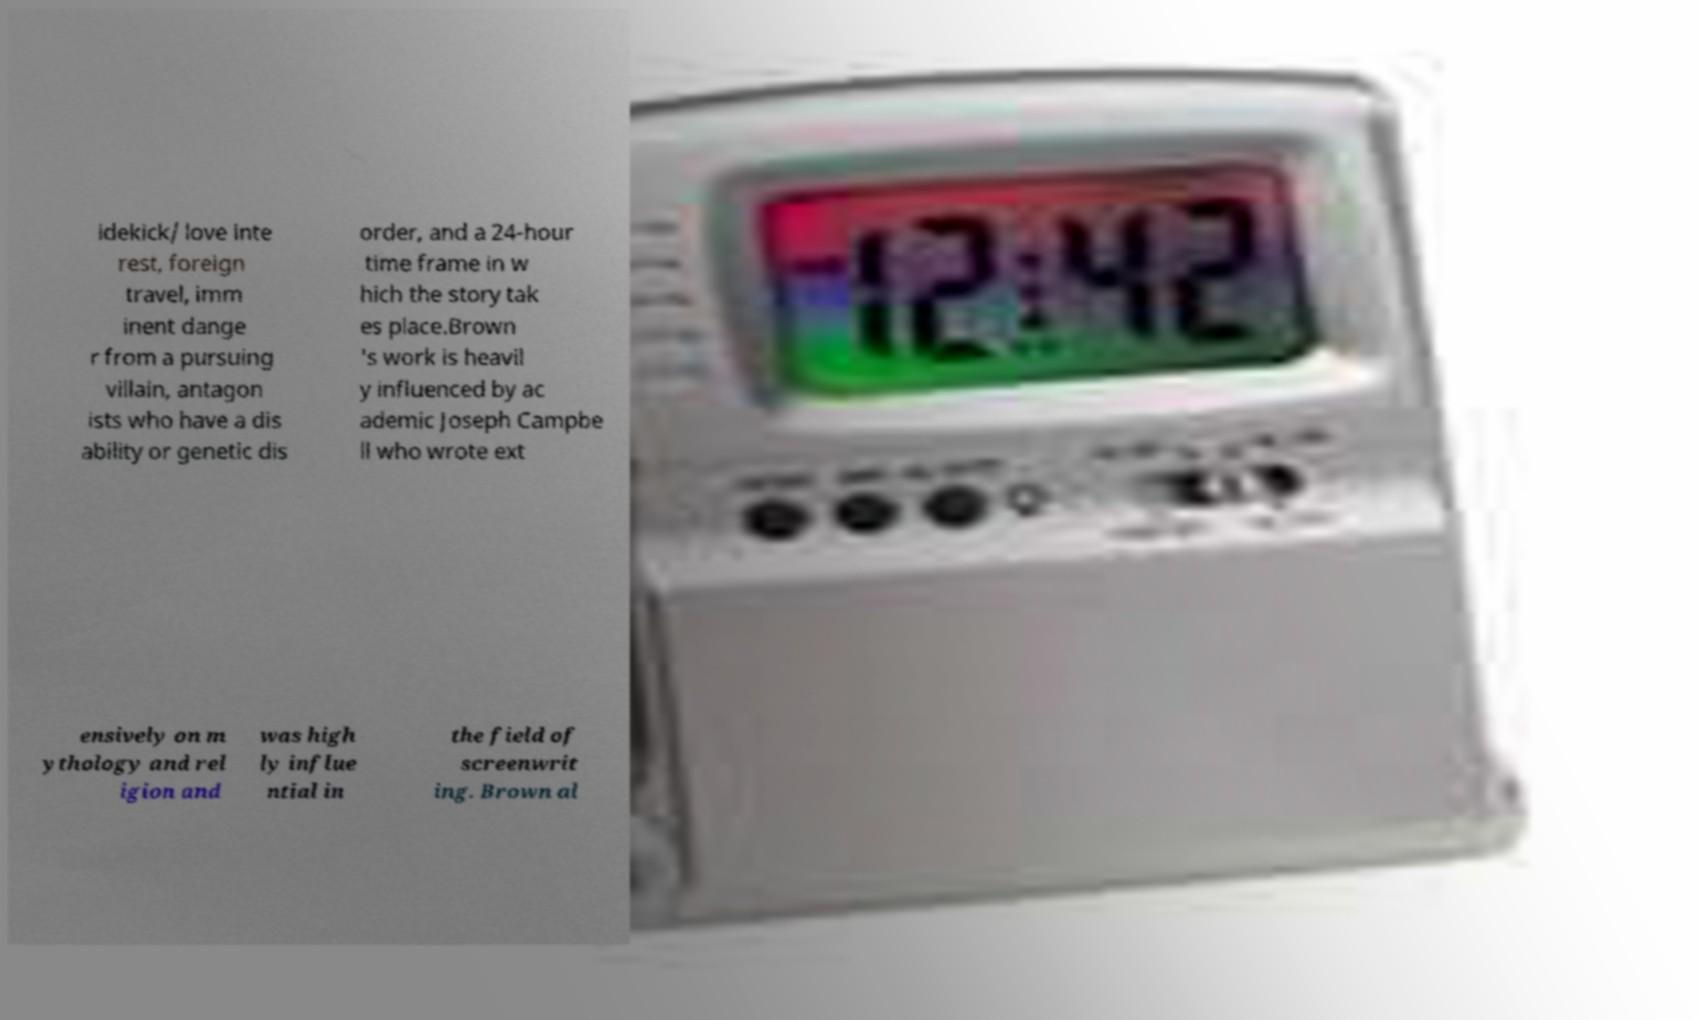Could you assist in decoding the text presented in this image and type it out clearly? idekick/ love inte rest, foreign travel, imm inent dange r from a pursuing villain, antagon ists who have a dis ability or genetic dis order, and a 24-hour time frame in w hich the story tak es place.Brown 's work is heavil y influenced by ac ademic Joseph Campbe ll who wrote ext ensively on m ythology and rel igion and was high ly influe ntial in the field of screenwrit ing. Brown al 